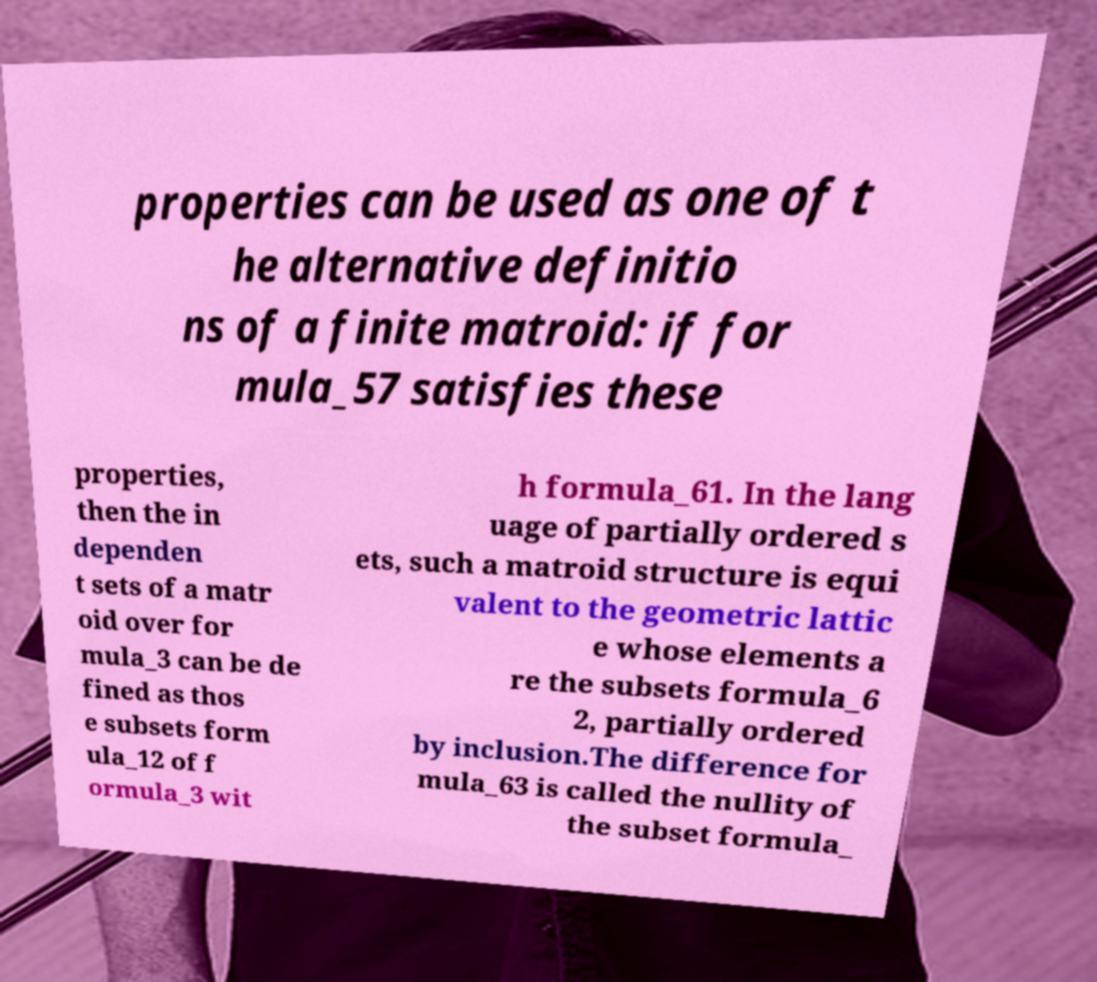Could you extract and type out the text from this image? properties can be used as one of t he alternative definitio ns of a finite matroid: if for mula_57 satisfies these properties, then the in dependen t sets of a matr oid over for mula_3 can be de fined as thos e subsets form ula_12 of f ormula_3 wit h formula_61. In the lang uage of partially ordered s ets, such a matroid structure is equi valent to the geometric lattic e whose elements a re the subsets formula_6 2, partially ordered by inclusion.The difference for mula_63 is called the nullity of the subset formula_ 